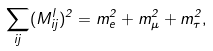<formula> <loc_0><loc_0><loc_500><loc_500>\sum _ { i j } ( M _ { i j } ^ { l } ) ^ { 2 } = m _ { e } ^ { 2 } + m _ { \mu } ^ { 2 } + m _ { \tau } ^ { 2 } ,</formula> 